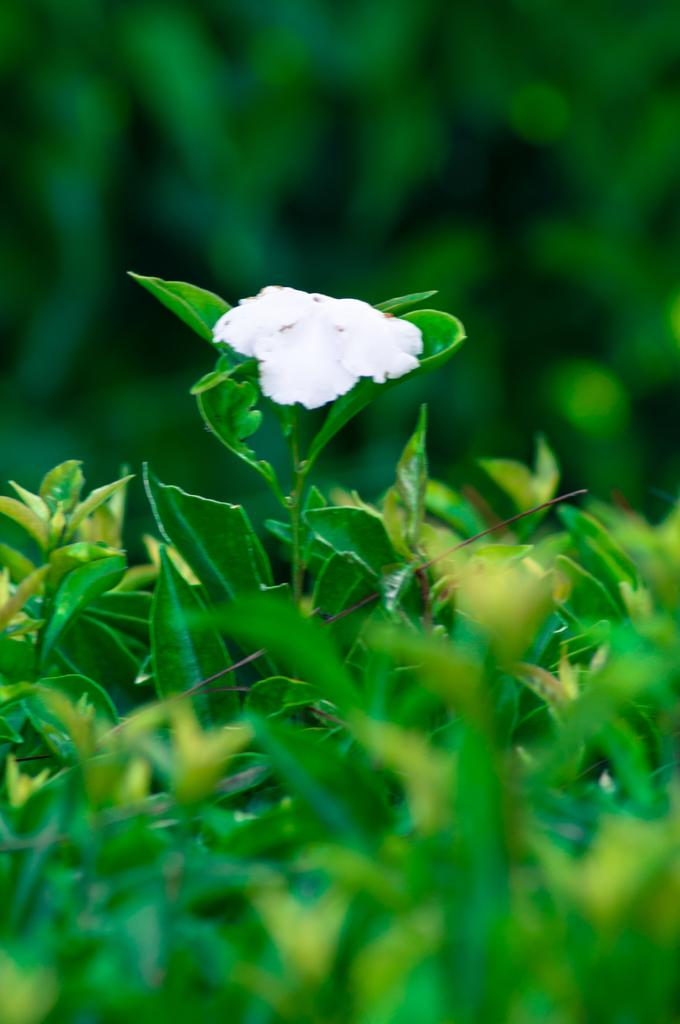What type of flower is in the image? There is a white flower in the image. What can be seen in the background of the image? The background of the image includes leaves. How would you describe the clarity of the image? The image is blurry. What is the profit margin of the volleyball team mentioned in the image? There is no mention of a volleyball team or profit margin in the image; it features a white flower and leaves in the background. 